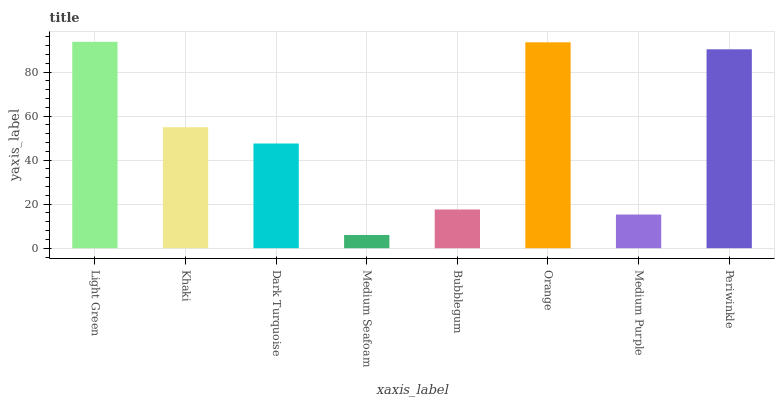Is Medium Seafoam the minimum?
Answer yes or no. Yes. Is Light Green the maximum?
Answer yes or no. Yes. Is Khaki the minimum?
Answer yes or no. No. Is Khaki the maximum?
Answer yes or no. No. Is Light Green greater than Khaki?
Answer yes or no. Yes. Is Khaki less than Light Green?
Answer yes or no. Yes. Is Khaki greater than Light Green?
Answer yes or no. No. Is Light Green less than Khaki?
Answer yes or no. No. Is Khaki the high median?
Answer yes or no. Yes. Is Dark Turquoise the low median?
Answer yes or no. Yes. Is Dark Turquoise the high median?
Answer yes or no. No. Is Periwinkle the low median?
Answer yes or no. No. 